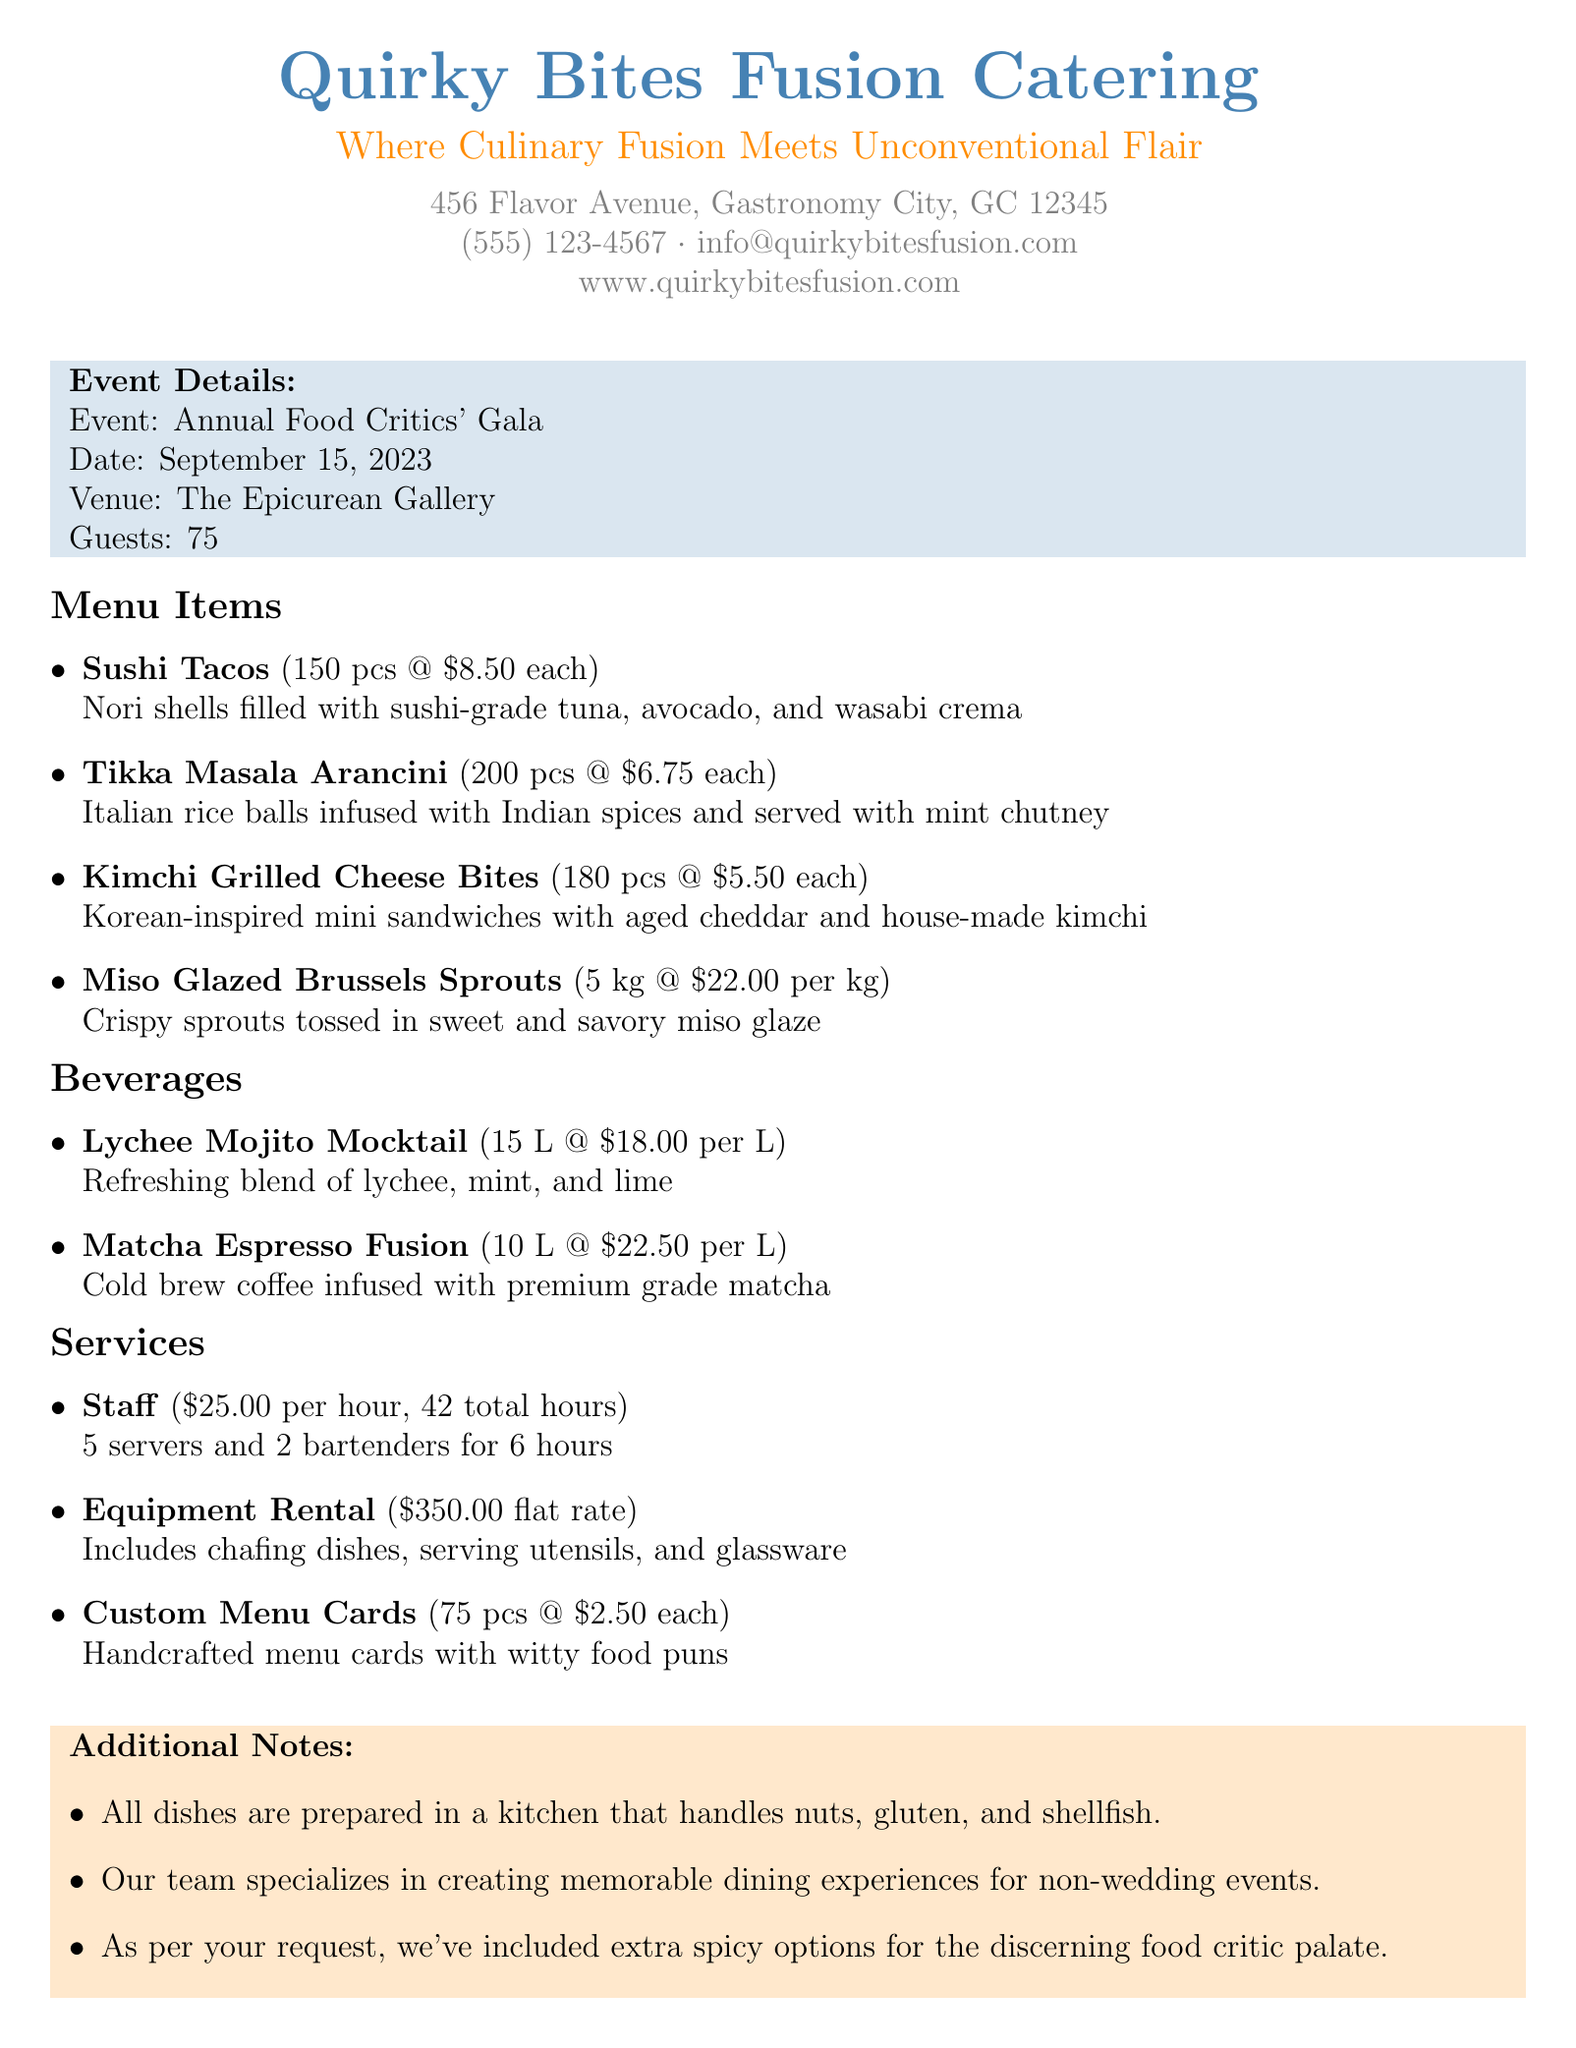What is the name of the catering company? The name of the catering company is stated at the top of the document.
Answer: Quirky Bites Fusion Catering What is the event date? The date of the event is specified in the event details section.
Answer: September 15, 2023 How many guests are expected? The number of guests is included in the event details section.
Answer: 75 What is the price per piece for Sushi Tacos? The price for Sushi Tacos is provided in the menu items section.
Answer: 8.50 How many liters of Lychee Mojito Mocktail were ordered? The quantity of Lychee Mojito Mocktail is listed in the beverages section.
Answer: 15 What is the total hourly cost for staff? The total cost for staff can be calculated from the price per hour and total hours worked.
Answer: 1,050.00 What is the flat rate for equipment rental? The flat rate for equipment rental is mentioned in the services section.
Answer: 350.00 What is the cancellation policy? The cancellation policy is described in the last section of the document.
Answer: Full refund if cancelled 30 days prior to the event What is included in the additional notes? The additional notes section contains various important reminders regarding the preparation of the dishes.
Answer: All dishes are prepared in a kitchen that handles nuts, gluten, and shellfish 